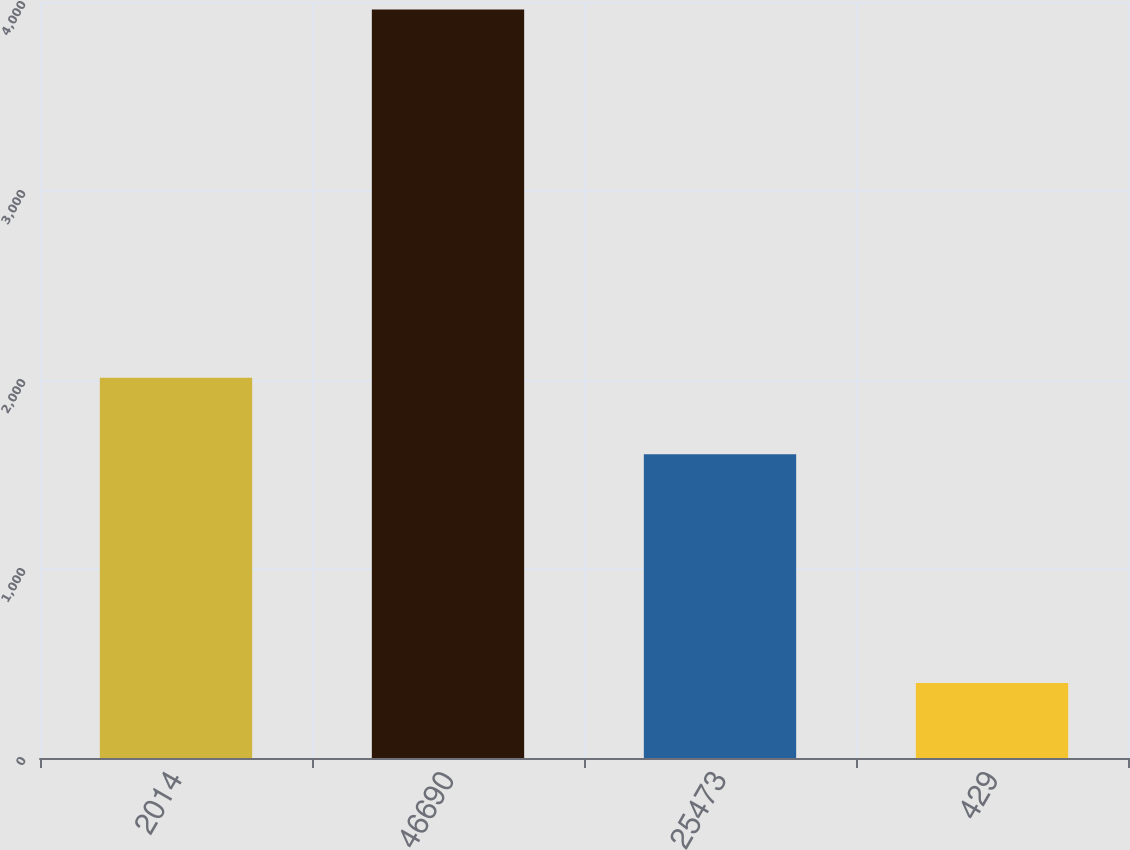Convert chart to OTSL. <chart><loc_0><loc_0><loc_500><loc_500><bar_chart><fcel>2014<fcel>46690<fcel>25473<fcel>429<nl><fcel>2012<fcel>3960.9<fcel>1607.4<fcel>396.6<nl></chart> 